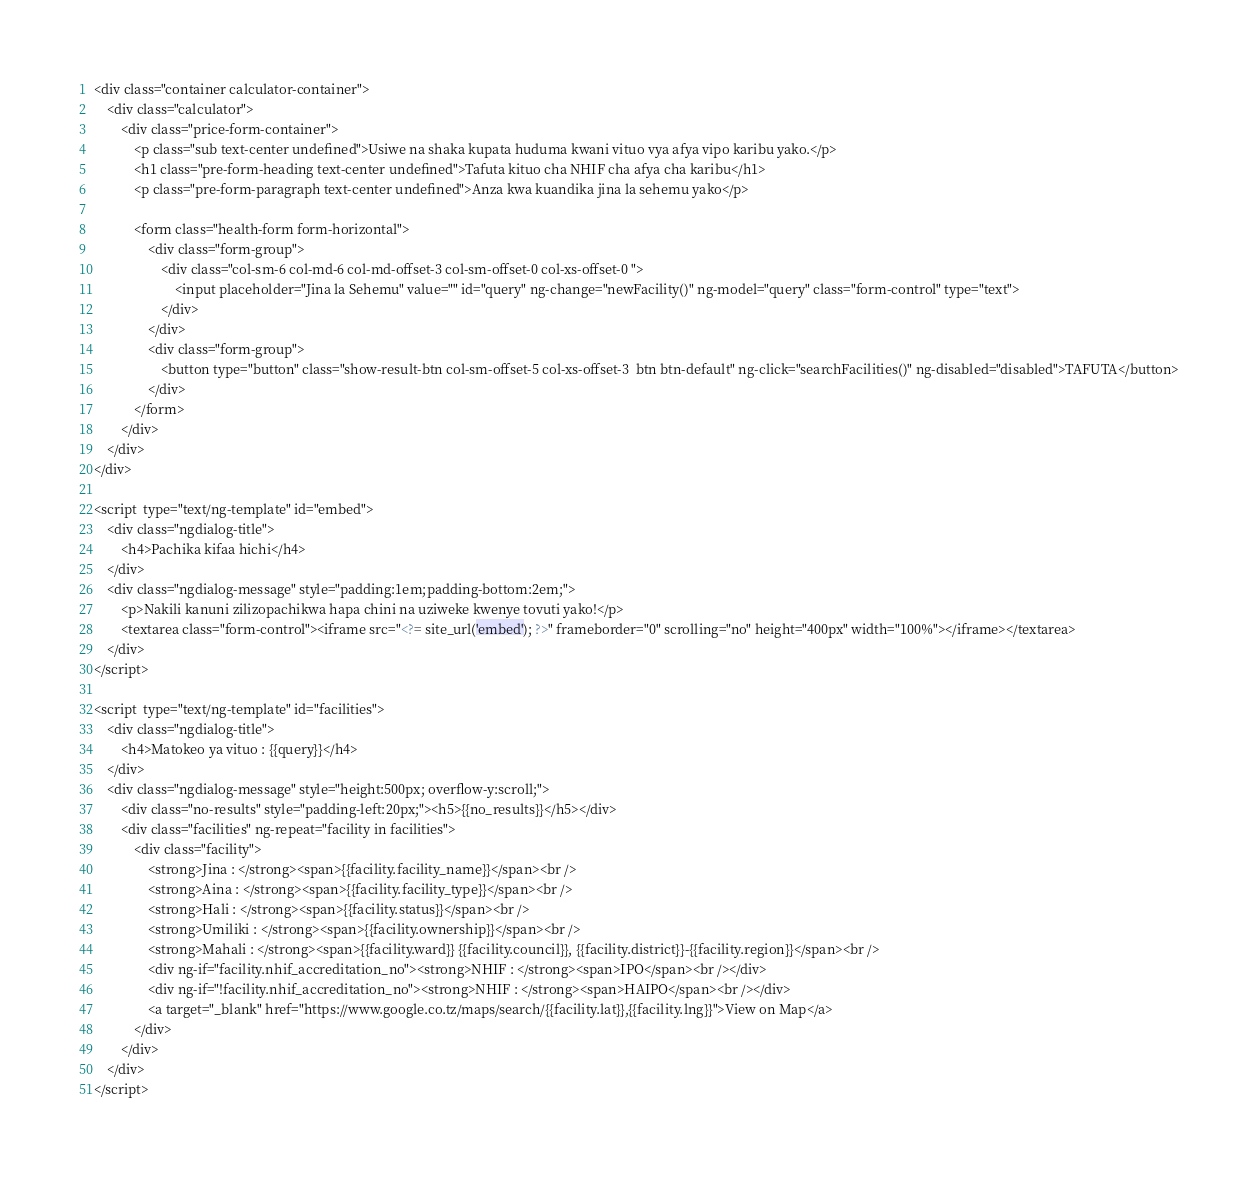Convert code to text. <code><loc_0><loc_0><loc_500><loc_500><_PHP_><div class="container calculator-container">
    <div class="calculator">
        <div class="price-form-container">
            <p class="sub text-center undefined">Usiwe na shaka kupata huduma kwani vituo vya afya vipo karibu yako.</p>
            <h1 class="pre-form-heading text-center undefined">Tafuta kituo cha NHIF cha afya cha karibu</h1>
            <p class="pre-form-paragraph text-center undefined">Anza kwa kuandika jina la sehemu yako</p>

            <form class="health-form form-horizontal">
                <div class="form-group">
                    <div class="col-sm-6 col-md-6 col-md-offset-3 col-sm-offset-0 col-xs-offset-0 ">
                        <input placeholder="Jina la Sehemu" value="" id="query" ng-change="newFacility()" ng-model="query" class="form-control" type="text">
                    </div>
                </div>
                <div class="form-group">
                    <button type="button" class="show-result-btn col-sm-offset-5 col-xs-offset-3  btn btn-default" ng-click="searchFacilities()" ng-disabled="disabled">TAFUTA</button>
                </div>
            </form>
        </div>
    </div>
</div>

<script  type="text/ng-template" id="embed">
    <div class="ngdialog-title">
        <h4>Pachika kifaa hichi</h4>
    </div>
    <div class="ngdialog-message" style="padding:1em;padding-bottom:2em;">
        <p>Nakili kanuni zilizopachikwa hapa chini na uziweke kwenye tovuti yako!</p>
        <textarea class="form-control"><iframe src="<?= site_url('embed'); ?>" frameborder="0" scrolling="no" height="400px" width="100%"></iframe></textarea>
    </div>
</script>

<script  type="text/ng-template" id="facilities">
    <div class="ngdialog-title">
        <h4>Matokeo ya vituo : {{query}}</h4>
    </div>
    <div class="ngdialog-message" style="height:500px; overflow-y:scroll;">
        <div class="no-results" style="padding-left:20px;"><h5>{{no_results}}</h5></div>
        <div class="facilities" ng-repeat="facility in facilities">
            <div class="facility">
                <strong>Jina : </strong><span>{{facility.facility_name}}</span><br />
                <strong>Aina : </strong><span>{{facility.facility_type}}</span><br />
                <strong>Hali : </strong><span>{{facility.status}}</span><br />
                <strong>Umiliki : </strong><span>{{facility.ownership}}</span><br />
                <strong>Mahali : </strong><span>{{facility.ward}} {{facility.council}}, {{facility.district}}-{{facility.region}}</span><br />
                <div ng-if="facility.nhif_accreditation_no"><strong>NHIF : </strong><span>IPO</span><br /></div>
                <div ng-if="!facility.nhif_accreditation_no"><strong>NHIF : </strong><span>HAIPO</span><br /></div>
                <a target="_blank" href="https://www.google.co.tz/maps/search/{{facility.lat}},{{facility.lng}}">View on Map</a>
            </div>
        </div>
    </div>
</script></code> 